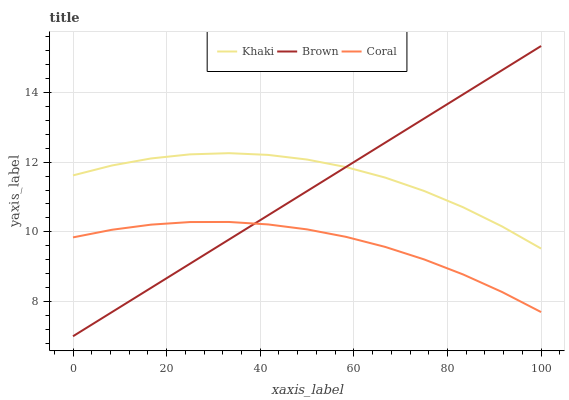Does Coral have the minimum area under the curve?
Answer yes or no. Yes. Does Khaki have the maximum area under the curve?
Answer yes or no. Yes. Does Khaki have the minimum area under the curve?
Answer yes or no. No. Does Coral have the maximum area under the curve?
Answer yes or no. No. Is Brown the smoothest?
Answer yes or no. Yes. Is Khaki the roughest?
Answer yes or no. Yes. Is Coral the smoothest?
Answer yes or no. No. Is Coral the roughest?
Answer yes or no. No. Does Brown have the lowest value?
Answer yes or no. Yes. Does Coral have the lowest value?
Answer yes or no. No. Does Brown have the highest value?
Answer yes or no. Yes. Does Khaki have the highest value?
Answer yes or no. No. Is Coral less than Khaki?
Answer yes or no. Yes. Is Khaki greater than Coral?
Answer yes or no. Yes. Does Brown intersect Coral?
Answer yes or no. Yes. Is Brown less than Coral?
Answer yes or no. No. Is Brown greater than Coral?
Answer yes or no. No. Does Coral intersect Khaki?
Answer yes or no. No. 